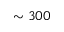<formula> <loc_0><loc_0><loc_500><loc_500>\sim 3 0 0</formula> 